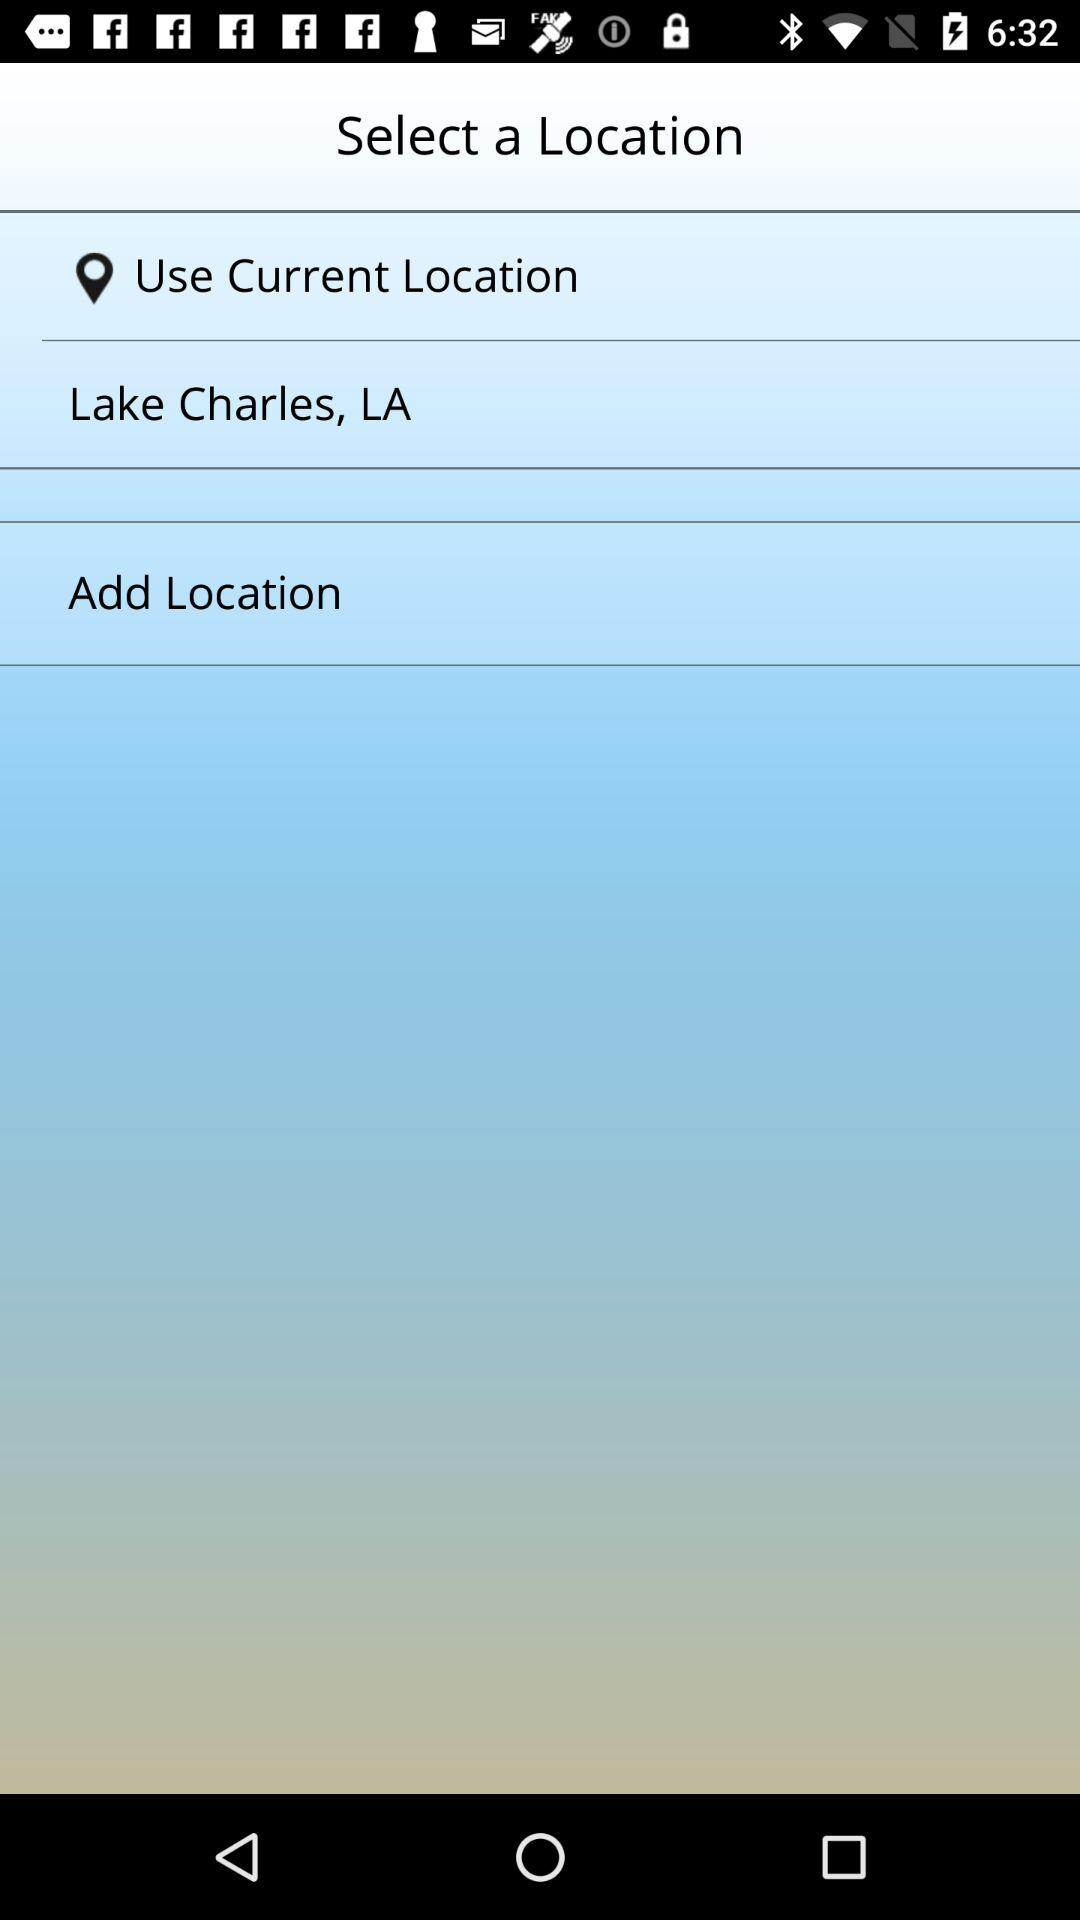How many location options are available?
Answer the question using a single word or phrase. 3 